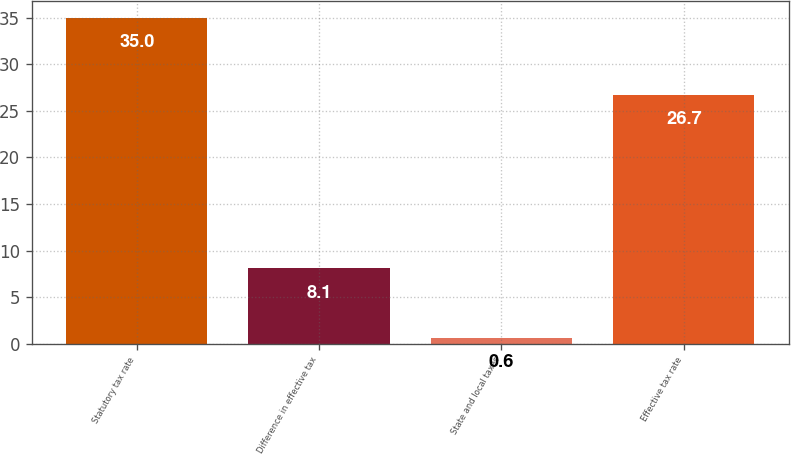<chart> <loc_0><loc_0><loc_500><loc_500><bar_chart><fcel>Statutory tax rate<fcel>Difference in effective tax<fcel>State and local taxes<fcel>Effective tax rate<nl><fcel>35<fcel>8.1<fcel>0.6<fcel>26.7<nl></chart> 